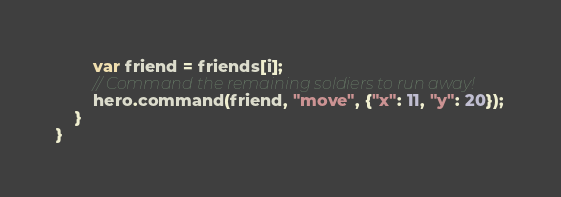<code> <loc_0><loc_0><loc_500><loc_500><_JavaScript_>        var friend = friends[i];
        // Command the remaining soldiers to run away!
        hero.command(friend, "move", {"x": 11, "y": 20});
    }
}
</code> 